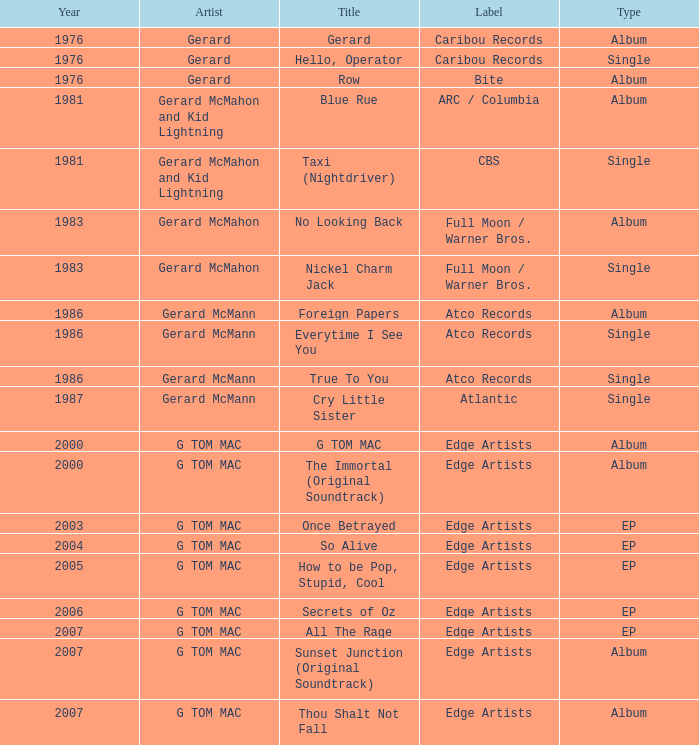Which category possesses a title of "so alive"? EP. 